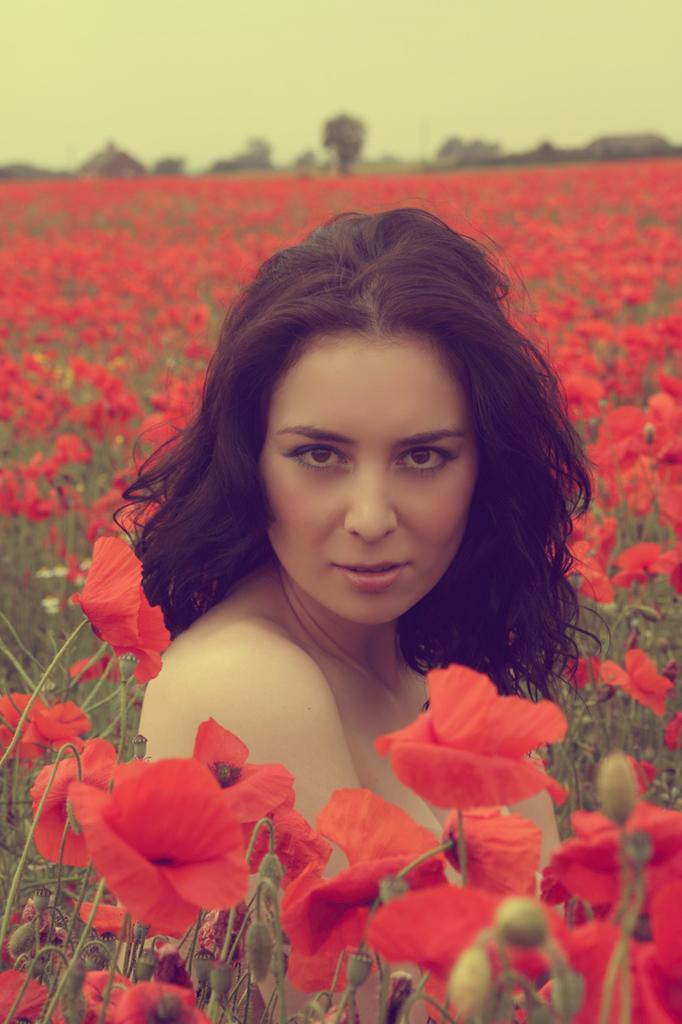Who is present in the image? There is a woman in the image. What type of plants can be seen in the image? There are plants with red flowers in the image. What can be seen in the background of the image? There are trees and the sky visible in the background of the image. What type of beam is holding up the clouds in the image? There is no beam present in the image, and the clouds are not being held up by any visible structure. 